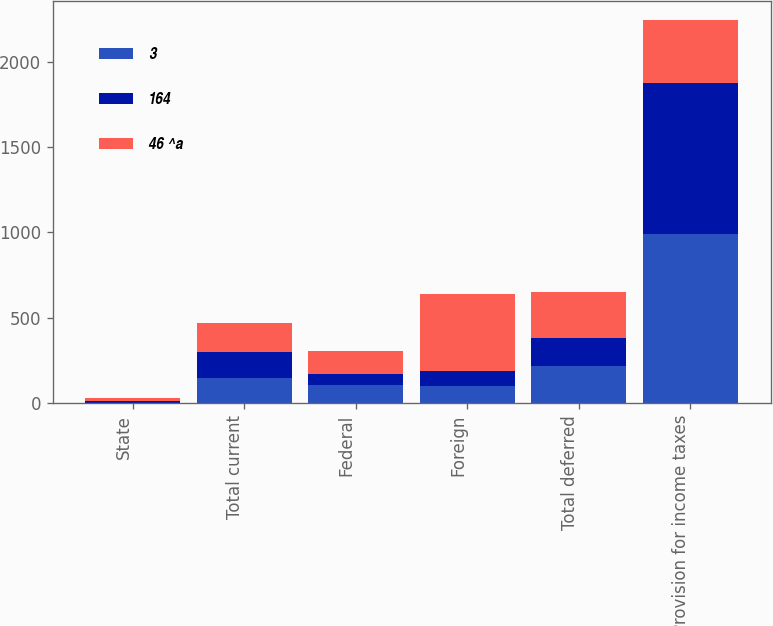Convert chart. <chart><loc_0><loc_0><loc_500><loc_500><stacked_bar_chart><ecel><fcel>State<fcel>Total current<fcel>Federal<fcel>Foreign<fcel>Total deferred<fcel>Provision for income taxes<nl><fcel>3<fcel>1<fcel>150<fcel>106<fcel>102<fcel>216<fcel>991<nl><fcel>164<fcel>10<fcel>150<fcel>64<fcel>89<fcel>163<fcel>883<nl><fcel>46 ^a<fcel>17<fcel>171<fcel>137<fcel>451<fcel>273<fcel>371<nl></chart> 